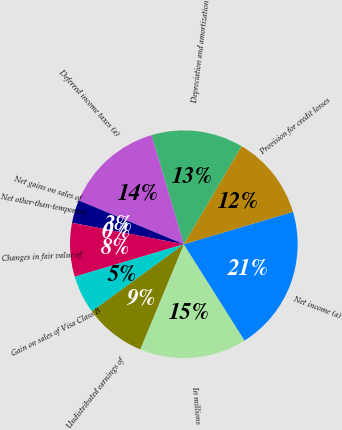Convert chart to OTSL. <chart><loc_0><loc_0><loc_500><loc_500><pie_chart><fcel>In millions<fcel>Net income (a)<fcel>Provision for credit losses<fcel>Depreciation and amortization<fcel>Deferred income taxes (a)<fcel>Net gains on sales of<fcel>Net other-than-temporary<fcel>Changes in fair value of<fcel>Gain on sales of Visa Class B<fcel>Undistributed earnings of<nl><fcel>15.21%<fcel>20.64%<fcel>11.95%<fcel>13.04%<fcel>14.13%<fcel>3.27%<fcel>0.01%<fcel>7.61%<fcel>5.44%<fcel>8.7%<nl></chart> 